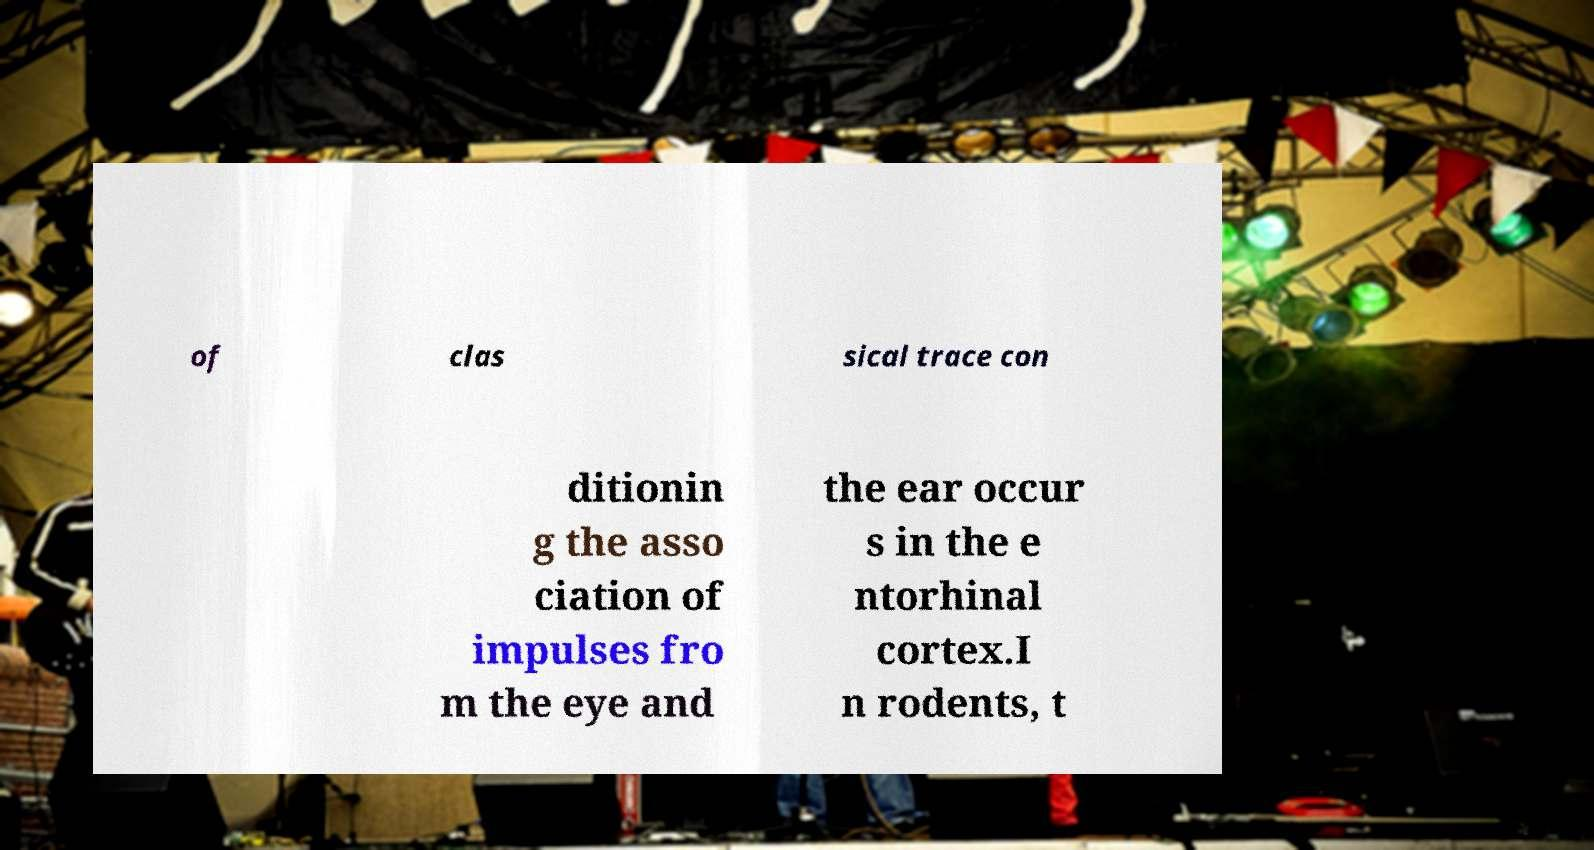There's text embedded in this image that I need extracted. Can you transcribe it verbatim? of clas sical trace con ditionin g the asso ciation of impulses fro m the eye and the ear occur s in the e ntorhinal cortex.I n rodents, t 